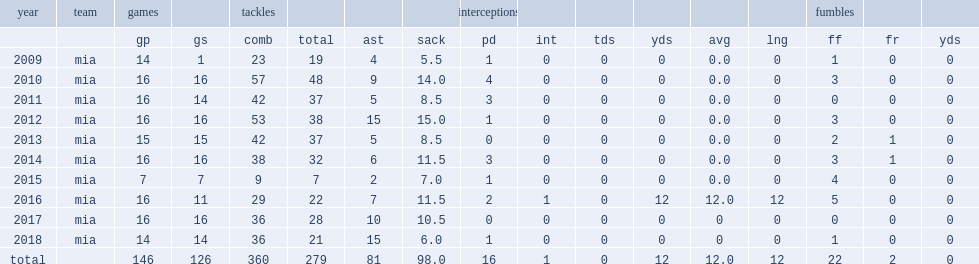How many sacks did cameron wake finish the season with? 11.5. 